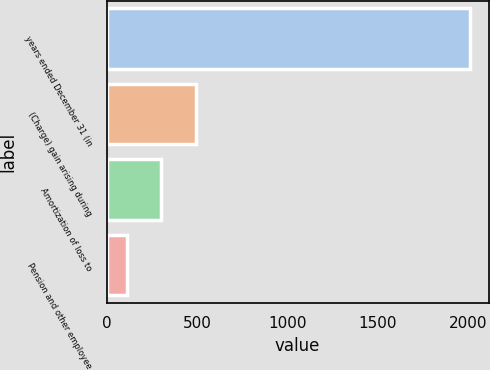<chart> <loc_0><loc_0><loc_500><loc_500><bar_chart><fcel>years ended December 31 (in<fcel>(Charge) gain arising during<fcel>Amortization of loss to<fcel>Pension and other employee<nl><fcel>2012<fcel>491.2<fcel>301.1<fcel>111<nl></chart> 